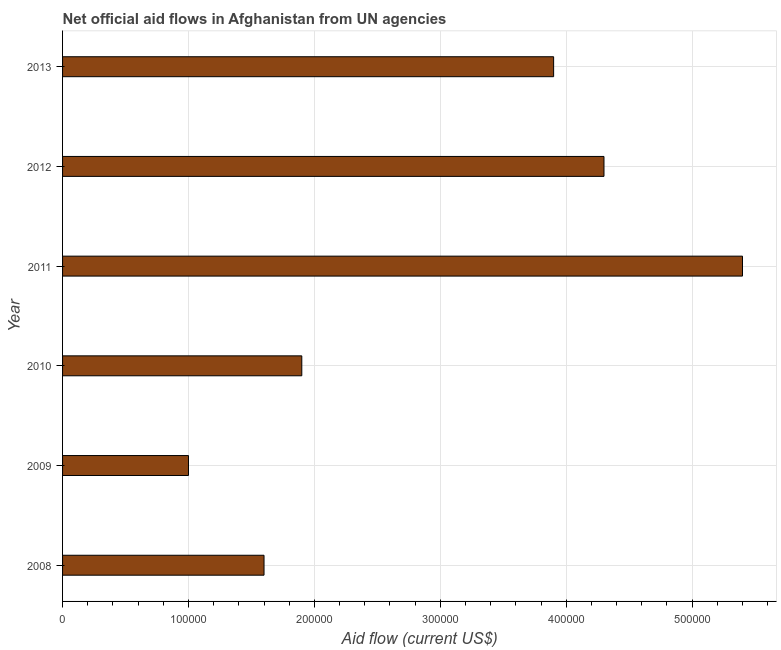Does the graph contain grids?
Offer a terse response. Yes. What is the title of the graph?
Offer a terse response. Net official aid flows in Afghanistan from UN agencies. What is the net official flows from un agencies in 2011?
Offer a terse response. 5.40e+05. Across all years, what is the maximum net official flows from un agencies?
Give a very brief answer. 5.40e+05. Across all years, what is the minimum net official flows from un agencies?
Make the answer very short. 1.00e+05. What is the sum of the net official flows from un agencies?
Give a very brief answer. 1.81e+06. What is the average net official flows from un agencies per year?
Provide a succinct answer. 3.02e+05. In how many years, is the net official flows from un agencies greater than 240000 US$?
Offer a terse response. 3. What is the ratio of the net official flows from un agencies in 2011 to that in 2013?
Make the answer very short. 1.39. Is the difference between the net official flows from un agencies in 2008 and 2012 greater than the difference between any two years?
Your answer should be compact. No. What is the difference between the highest and the lowest net official flows from un agencies?
Offer a terse response. 4.40e+05. What is the difference between two consecutive major ticks on the X-axis?
Keep it short and to the point. 1.00e+05. What is the Aid flow (current US$) of 2011?
Ensure brevity in your answer.  5.40e+05. What is the difference between the Aid flow (current US$) in 2008 and 2009?
Your answer should be very brief. 6.00e+04. What is the difference between the Aid flow (current US$) in 2008 and 2010?
Your answer should be compact. -3.00e+04. What is the difference between the Aid flow (current US$) in 2008 and 2011?
Provide a short and direct response. -3.80e+05. What is the difference between the Aid flow (current US$) in 2009 and 2010?
Make the answer very short. -9.00e+04. What is the difference between the Aid flow (current US$) in 2009 and 2011?
Ensure brevity in your answer.  -4.40e+05. What is the difference between the Aid flow (current US$) in 2009 and 2012?
Your answer should be very brief. -3.30e+05. What is the difference between the Aid flow (current US$) in 2010 and 2011?
Provide a short and direct response. -3.50e+05. What is the difference between the Aid flow (current US$) in 2010 and 2013?
Ensure brevity in your answer.  -2.00e+05. What is the difference between the Aid flow (current US$) in 2011 and 2013?
Make the answer very short. 1.50e+05. What is the difference between the Aid flow (current US$) in 2012 and 2013?
Provide a succinct answer. 4.00e+04. What is the ratio of the Aid flow (current US$) in 2008 to that in 2010?
Ensure brevity in your answer.  0.84. What is the ratio of the Aid flow (current US$) in 2008 to that in 2011?
Keep it short and to the point. 0.3. What is the ratio of the Aid flow (current US$) in 2008 to that in 2012?
Offer a terse response. 0.37. What is the ratio of the Aid flow (current US$) in 2008 to that in 2013?
Give a very brief answer. 0.41. What is the ratio of the Aid flow (current US$) in 2009 to that in 2010?
Keep it short and to the point. 0.53. What is the ratio of the Aid flow (current US$) in 2009 to that in 2011?
Ensure brevity in your answer.  0.18. What is the ratio of the Aid flow (current US$) in 2009 to that in 2012?
Ensure brevity in your answer.  0.23. What is the ratio of the Aid flow (current US$) in 2009 to that in 2013?
Provide a short and direct response. 0.26. What is the ratio of the Aid flow (current US$) in 2010 to that in 2011?
Your response must be concise. 0.35. What is the ratio of the Aid flow (current US$) in 2010 to that in 2012?
Keep it short and to the point. 0.44. What is the ratio of the Aid flow (current US$) in 2010 to that in 2013?
Give a very brief answer. 0.49. What is the ratio of the Aid flow (current US$) in 2011 to that in 2012?
Make the answer very short. 1.26. What is the ratio of the Aid flow (current US$) in 2011 to that in 2013?
Provide a succinct answer. 1.39. What is the ratio of the Aid flow (current US$) in 2012 to that in 2013?
Make the answer very short. 1.1. 